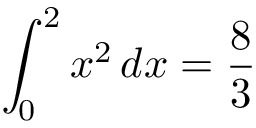<formula> <loc_0><loc_0><loc_500><loc_500>\int _ { 0 } ^ { 2 } x ^ { 2 } \, d x = { \frac { 8 } { 3 } }</formula> 